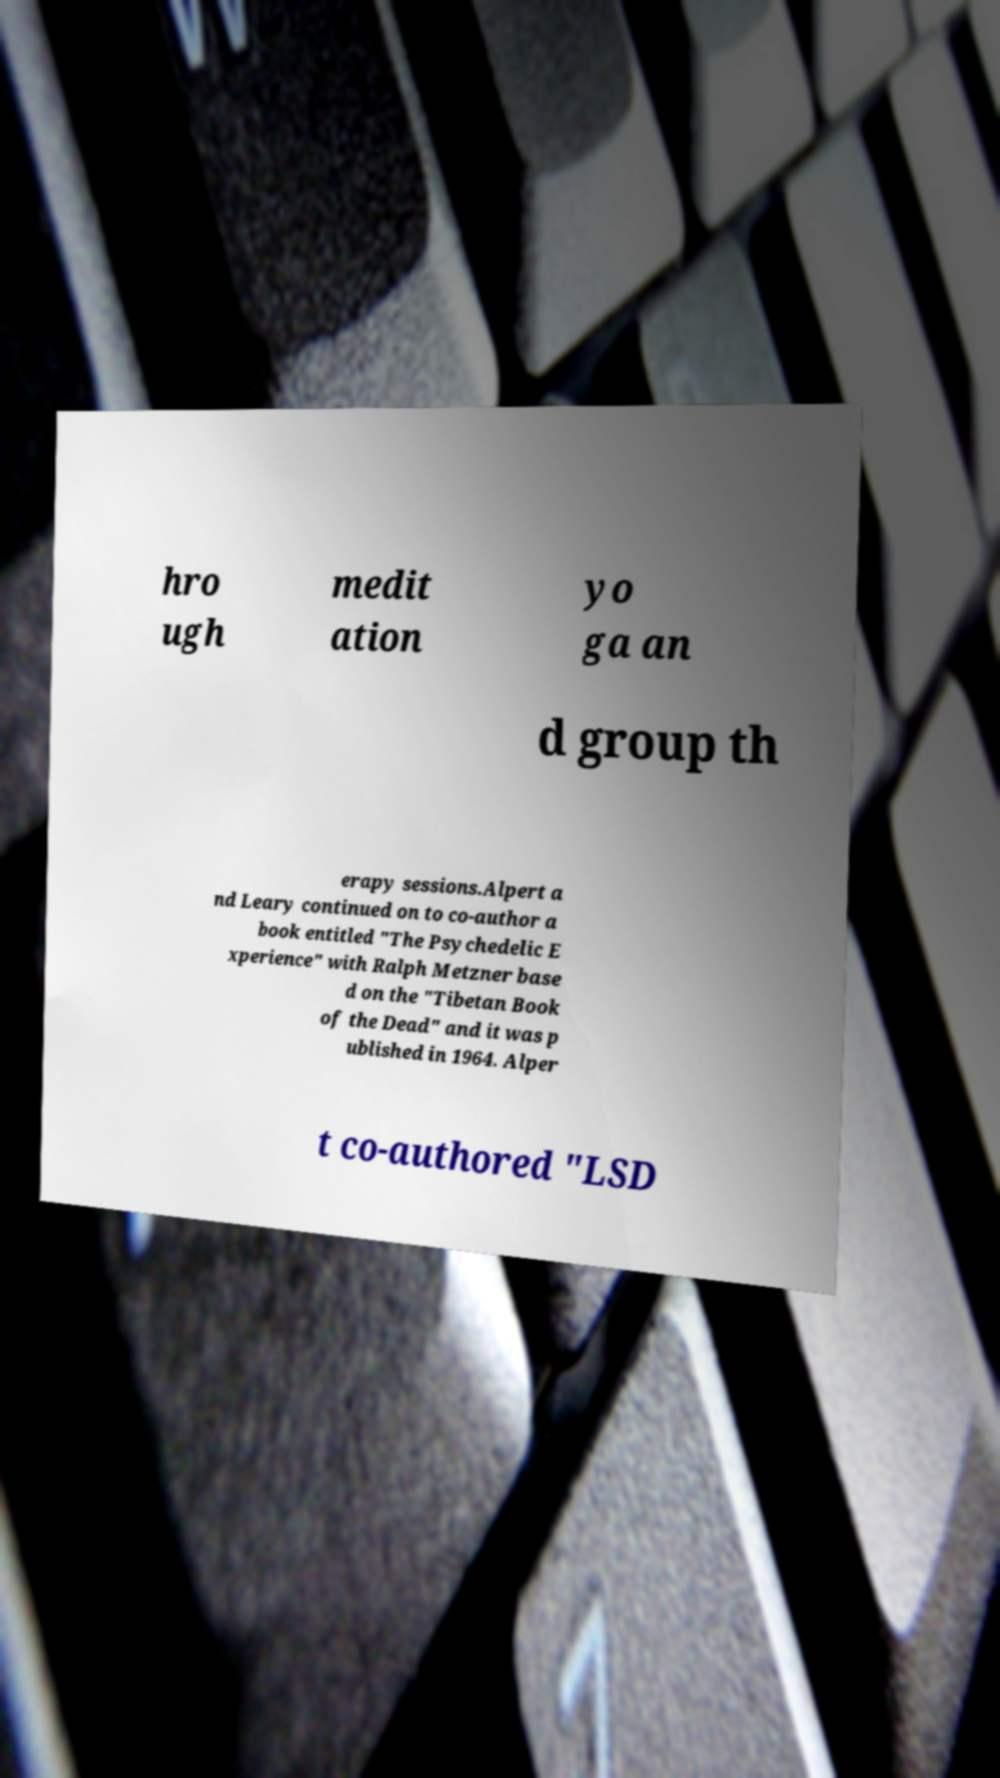There's text embedded in this image that I need extracted. Can you transcribe it verbatim? hro ugh medit ation yo ga an d group th erapy sessions.Alpert a nd Leary continued on to co-author a book entitled "The Psychedelic E xperience" with Ralph Metzner base d on the "Tibetan Book of the Dead" and it was p ublished in 1964. Alper t co-authored "LSD 